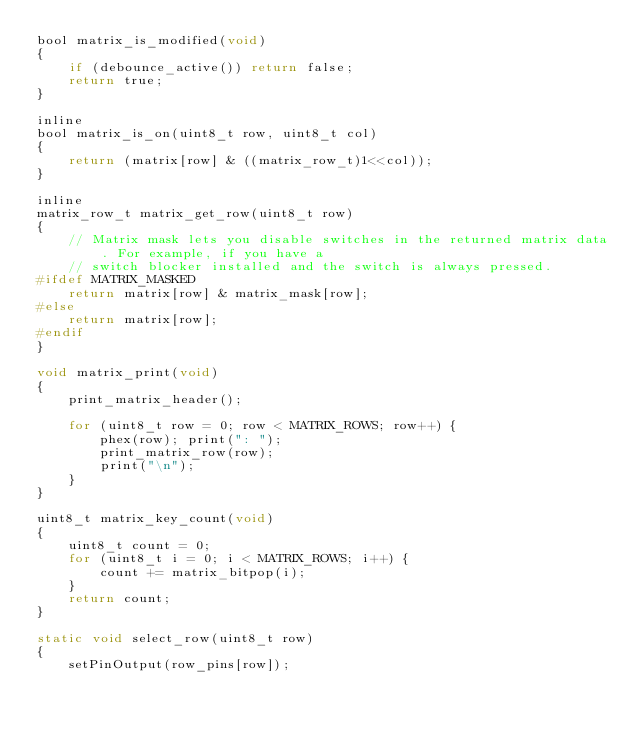Convert code to text. <code><loc_0><loc_0><loc_500><loc_500><_C_>bool matrix_is_modified(void)
{
    if (debounce_active()) return false;
    return true;
}

inline
bool matrix_is_on(uint8_t row, uint8_t col)
{
    return (matrix[row] & ((matrix_row_t)1<<col));
}

inline
matrix_row_t matrix_get_row(uint8_t row)
{
    // Matrix mask lets you disable switches in the returned matrix data. For example, if you have a
    // switch blocker installed and the switch is always pressed.
#ifdef MATRIX_MASKED
    return matrix[row] & matrix_mask[row];
#else
    return matrix[row];
#endif
}

void matrix_print(void)
{
    print_matrix_header();

    for (uint8_t row = 0; row < MATRIX_ROWS; row++) {
        phex(row); print(": ");
        print_matrix_row(row);
        print("\n");
    }
}

uint8_t matrix_key_count(void)
{
    uint8_t count = 0;
    for (uint8_t i = 0; i < MATRIX_ROWS; i++) {
        count += matrix_bitpop(i);
    }
    return count;
}

static void select_row(uint8_t row)
{
    setPinOutput(row_pins[row]);</code> 